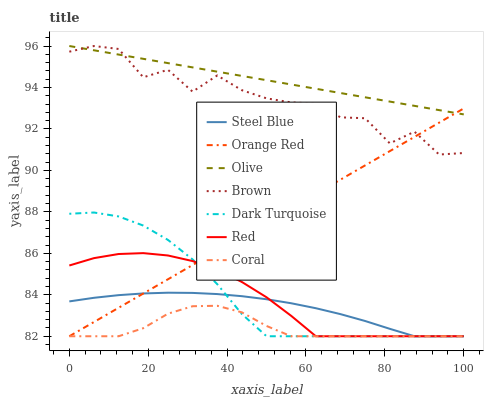Does Coral have the minimum area under the curve?
Answer yes or no. Yes. Does Olive have the maximum area under the curve?
Answer yes or no. Yes. Does Dark Turquoise have the minimum area under the curve?
Answer yes or no. No. Does Dark Turquoise have the maximum area under the curve?
Answer yes or no. No. Is Orange Red the smoothest?
Answer yes or no. Yes. Is Brown the roughest?
Answer yes or no. Yes. Is Dark Turquoise the smoothest?
Answer yes or no. No. Is Dark Turquoise the roughest?
Answer yes or no. No. Does Dark Turquoise have the lowest value?
Answer yes or no. Yes. Does Olive have the lowest value?
Answer yes or no. No. Does Olive have the highest value?
Answer yes or no. Yes. Does Dark Turquoise have the highest value?
Answer yes or no. No. Is Coral less than Brown?
Answer yes or no. Yes. Is Olive greater than Coral?
Answer yes or no. Yes. Does Brown intersect Olive?
Answer yes or no. Yes. Is Brown less than Olive?
Answer yes or no. No. Is Brown greater than Olive?
Answer yes or no. No. Does Coral intersect Brown?
Answer yes or no. No. 